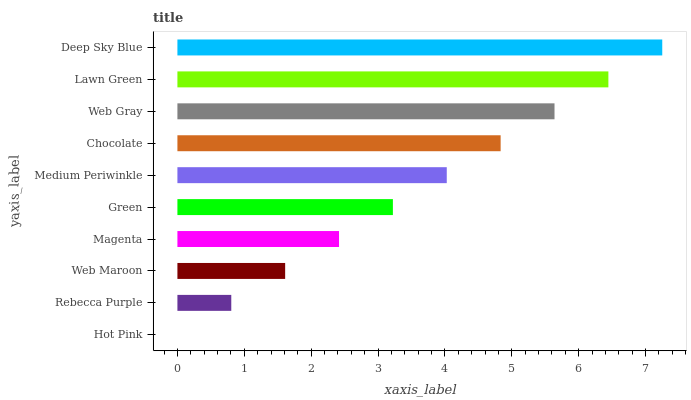Is Hot Pink the minimum?
Answer yes or no. Yes. Is Deep Sky Blue the maximum?
Answer yes or no. Yes. Is Rebecca Purple the minimum?
Answer yes or no. No. Is Rebecca Purple the maximum?
Answer yes or no. No. Is Rebecca Purple greater than Hot Pink?
Answer yes or no. Yes. Is Hot Pink less than Rebecca Purple?
Answer yes or no. Yes. Is Hot Pink greater than Rebecca Purple?
Answer yes or no. No. Is Rebecca Purple less than Hot Pink?
Answer yes or no. No. Is Medium Periwinkle the high median?
Answer yes or no. Yes. Is Green the low median?
Answer yes or no. Yes. Is Hot Pink the high median?
Answer yes or no. No. Is Medium Periwinkle the low median?
Answer yes or no. No. 